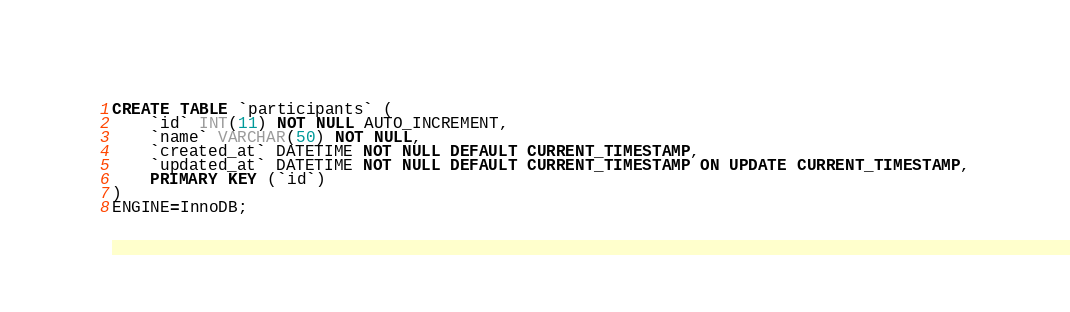Convert code to text. <code><loc_0><loc_0><loc_500><loc_500><_SQL_>CREATE TABLE `participants` (
	`id` INT(11) NOT NULL AUTO_INCREMENT,
	`name` VARCHAR(50) NOT NULL,
	`created_at` DATETIME NOT NULL DEFAULT CURRENT_TIMESTAMP,
	`updated_at` DATETIME NOT NULL DEFAULT CURRENT_TIMESTAMP ON UPDATE CURRENT_TIMESTAMP,
	PRIMARY KEY (`id`)
)
ENGINE=InnoDB;
</code> 